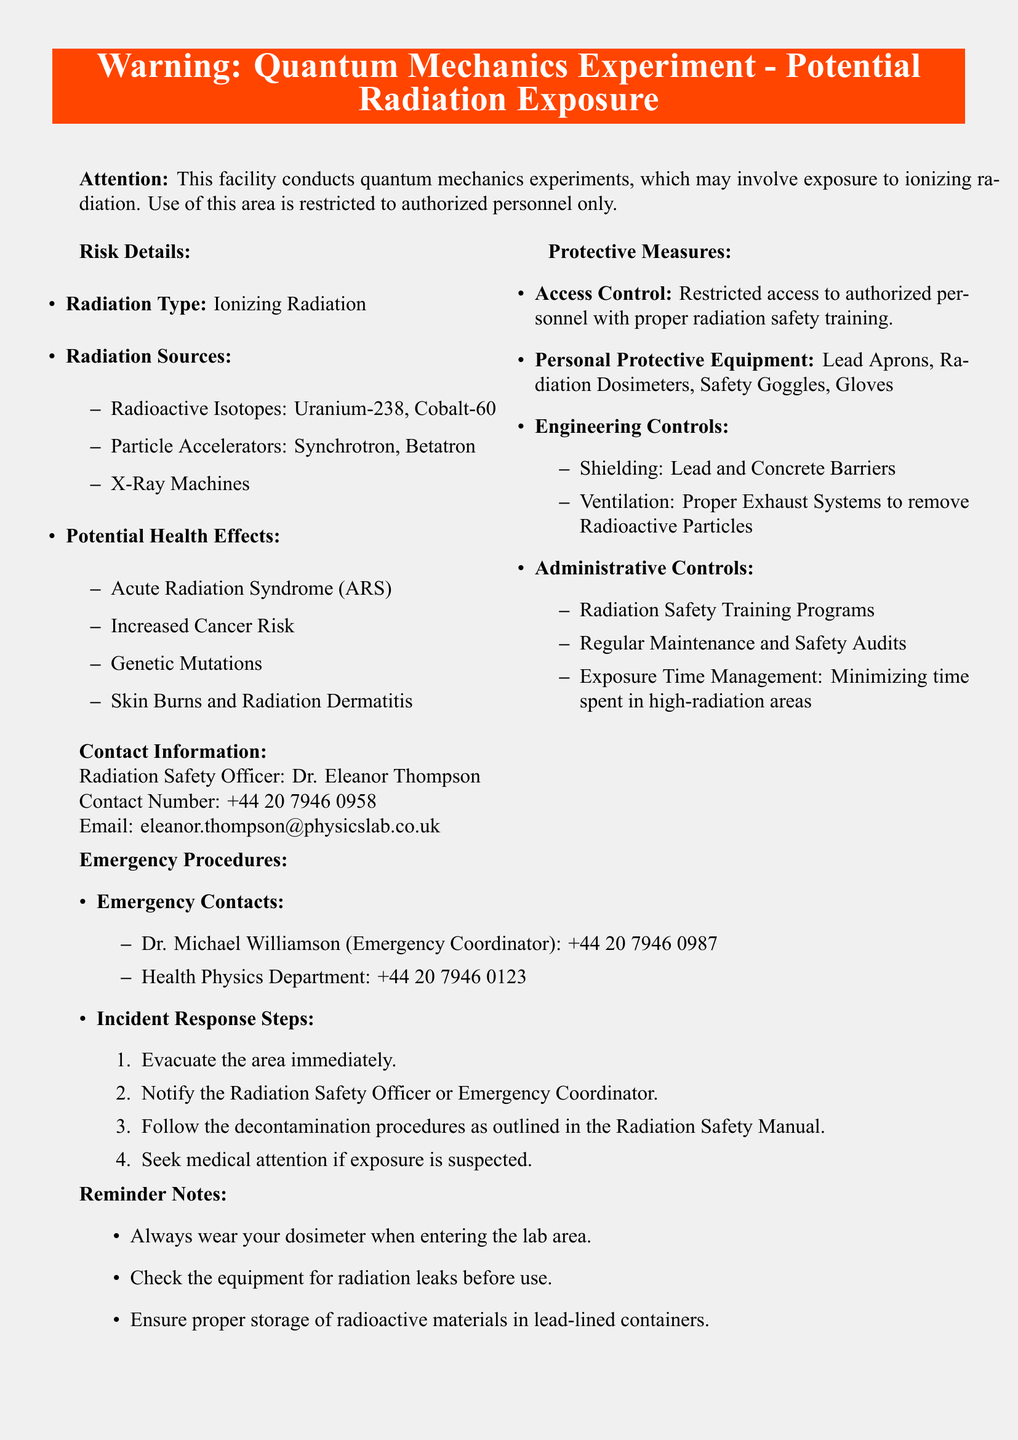What type of radiation is involved? The document states that the radiation involved is ionizing radiation.
Answer: Ionizing Radiation Who is the Radiation Safety Officer? The document provides the name of the Radiation Safety Officer as Dr. Eleanor Thompson.
Answer: Dr. Eleanor Thompson What are the potential health effects listed? The document lists several health effects, which include Acute Radiation Syndrome, Increased Cancer Risk, Genetic Mutations, and Skin Burns.
Answer: Acute Radiation Syndrome, Increased Cancer Risk, Genetic Mutations, Skin Burns What equipment is recommended for personal protection? The personal protective equipment mentioned in the document includes Lead Aprons, Radiation Dosimeters, Safety Goggles, and Gloves.
Answer: Lead Aprons, Radiation Dosimeters, Safety Goggles, Gloves How many sources of radiation are specified? The document outlines three types of radiation sources: radioactive isotopes, particle accelerators, and X-ray machines, which counts as three sources.
Answer: Three sources What is the emergency contact number for the Emergency Coordinator? The emergency contact number for the Emergency Coordinator is explicitly provided in the document.
Answer: +44 20 7946 0987 What does the first step of the incident response involve? The document specifies that the first step of the incident response is to evacuate the area immediately.
Answer: Evacuate the area immediately How should radioactive materials be stored? According to the document, radioactive materials must be stored in lead-lined containers.
Answer: Lead-lined containers What is the purpose of the dosimeter? The document mentions that the dosimeter is to be worn when entering the lab area.
Answer: Worn when entering the lab area What training is required for personnel accessing the area? The document states that personnel must have proper radiation safety training to access the area.
Answer: Proper radiation safety training 